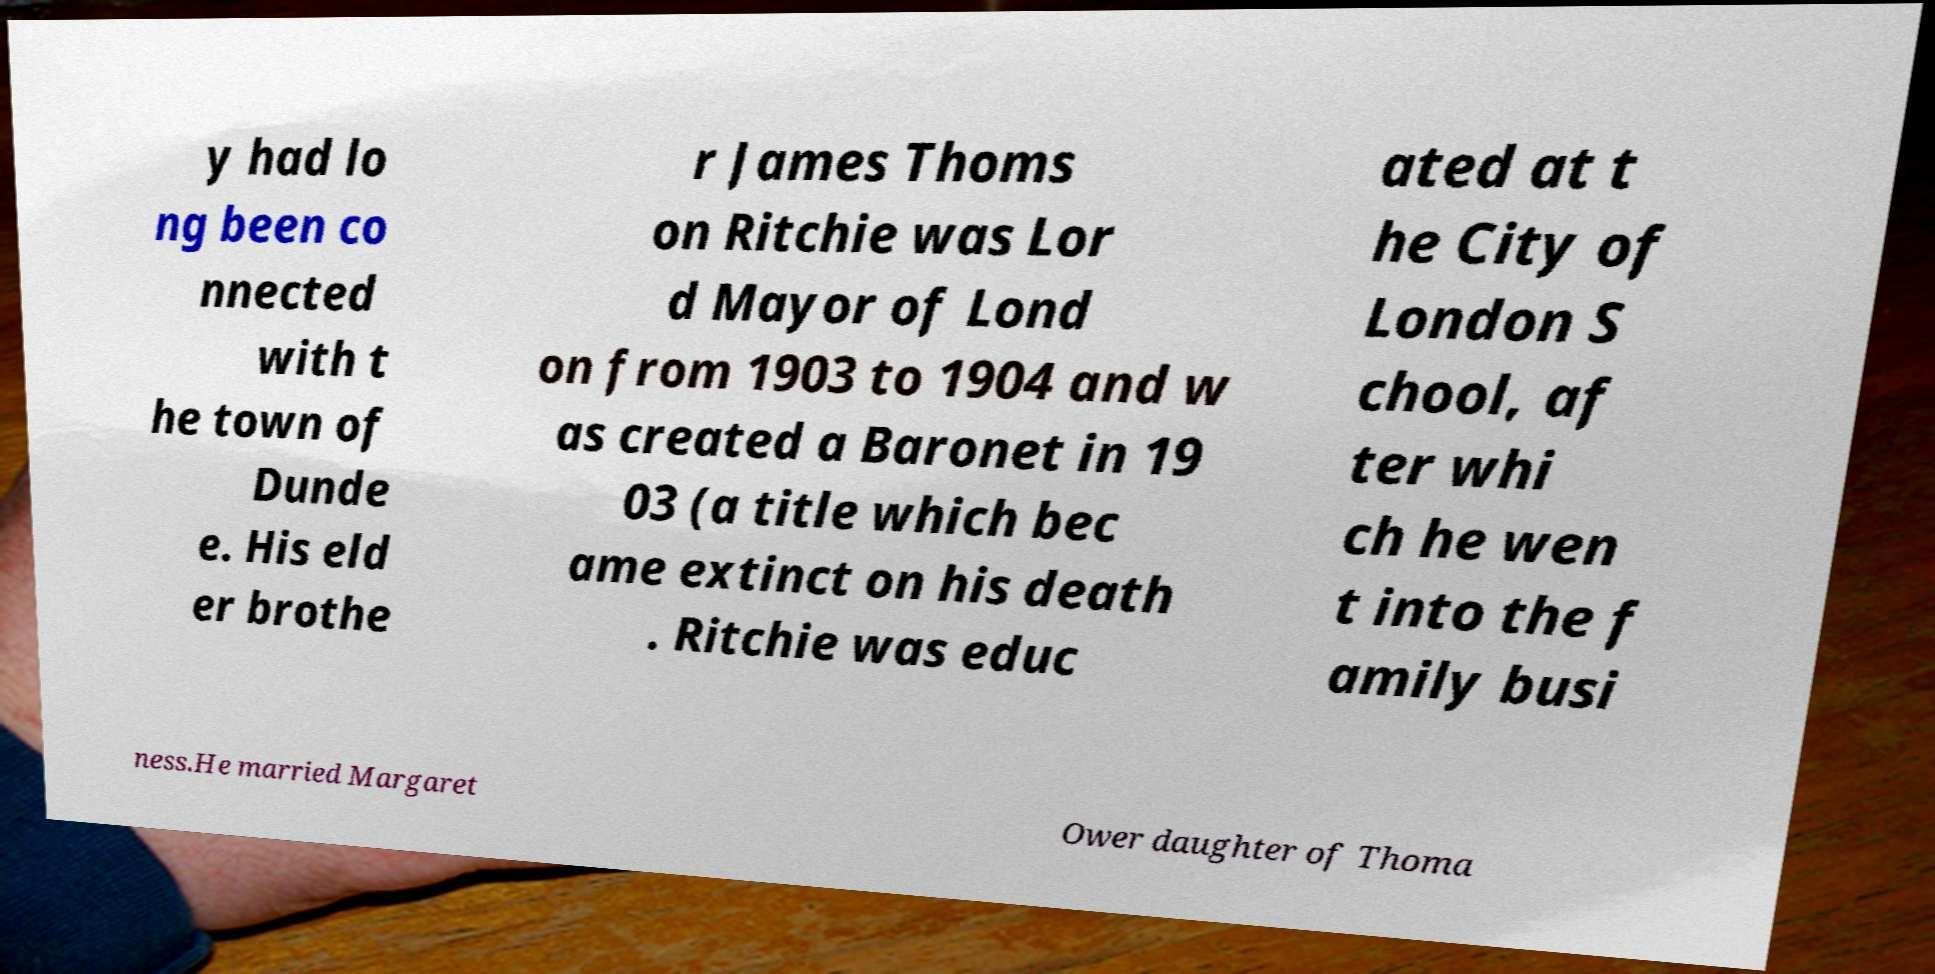Please identify and transcribe the text found in this image. y had lo ng been co nnected with t he town of Dunde e. His eld er brothe r James Thoms on Ritchie was Lor d Mayor of Lond on from 1903 to 1904 and w as created a Baronet in 19 03 (a title which bec ame extinct on his death . Ritchie was educ ated at t he City of London S chool, af ter whi ch he wen t into the f amily busi ness.He married Margaret Ower daughter of Thoma 